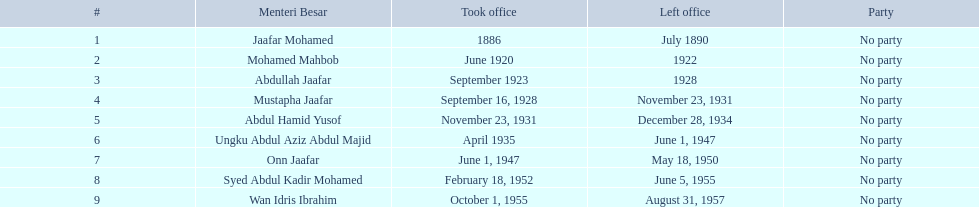What was the length of ungku abdul aziz abdul majid's service? 12 years. 